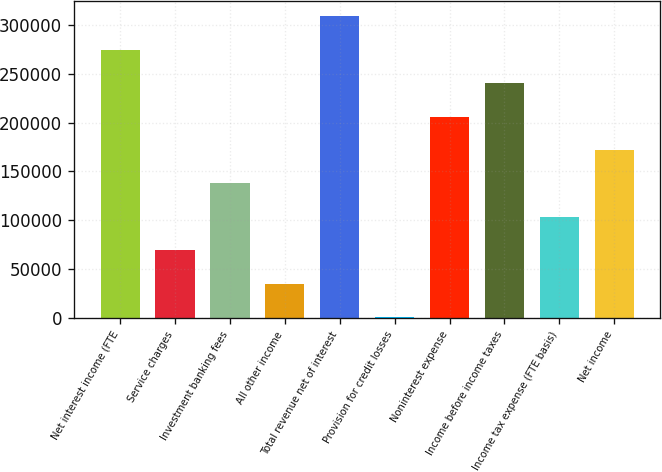Convert chart. <chart><loc_0><loc_0><loc_500><loc_500><bar_chart><fcel>Net interest income (FTE<fcel>Service charges<fcel>Investment banking fees<fcel>All other income<fcel>Total revenue net of interest<fcel>Provision for credit losses<fcel>Noninterest expense<fcel>Income before income taxes<fcel>Income tax expense (FTE basis)<fcel>Net income<nl><fcel>274433<fcel>69414.4<fcel>137754<fcel>35244.7<fcel>308602<fcel>1075<fcel>206093<fcel>240263<fcel>103584<fcel>171924<nl></chart> 